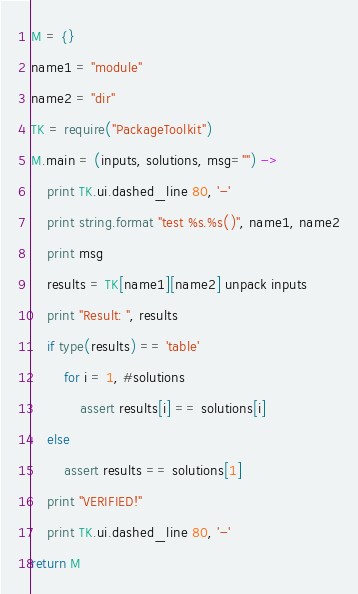<code> <loc_0><loc_0><loc_500><loc_500><_MoonScript_>M = {}
name1 = "module"
name2 = "dir"
TK = require("PackageToolkit")
M.main = (inputs, solutions, msg="") -> 
    print TK.ui.dashed_line 80, '-'
    print string.format "test %s.%s()", name1, name2
    print msg
    results = TK[name1][name2] unpack inputs
    print "Result: ", results
    if type(results) == 'table'
        for i = 1, #solutions
            assert results[i] == solutions[i]
    else
        assert results == solutions[1]
    print "VERIFIED!"
    print TK.ui.dashed_line 80, '-'
return M</code> 